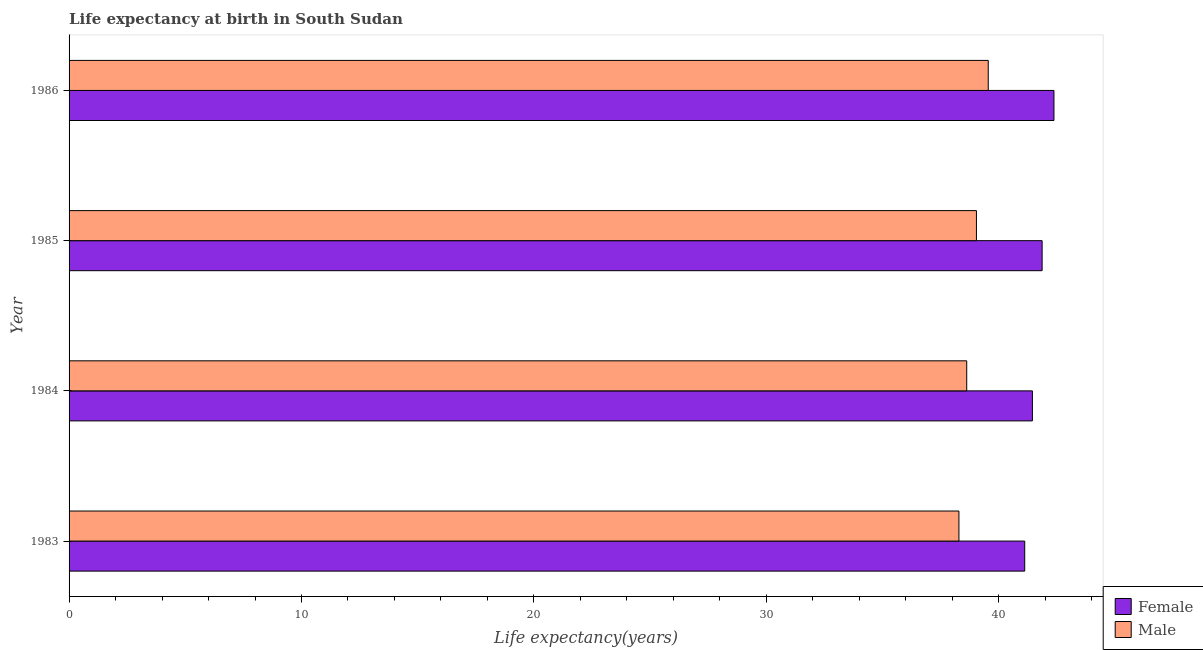How many different coloured bars are there?
Provide a short and direct response. 2. How many groups of bars are there?
Offer a terse response. 4. How many bars are there on the 3rd tick from the top?
Give a very brief answer. 2. How many bars are there on the 3rd tick from the bottom?
Provide a succinct answer. 2. What is the life expectancy(male) in 1986?
Keep it short and to the point. 39.55. Across all years, what is the maximum life expectancy(female)?
Give a very brief answer. 42.37. Across all years, what is the minimum life expectancy(male)?
Provide a succinct answer. 38.29. What is the total life expectancy(female) in the graph?
Your answer should be very brief. 166.8. What is the difference between the life expectancy(female) in 1984 and that in 1986?
Your response must be concise. -0.93. What is the difference between the life expectancy(female) in 1983 and the life expectancy(male) in 1986?
Provide a succinct answer. 1.57. What is the average life expectancy(female) per year?
Your answer should be compact. 41.7. In the year 1986, what is the difference between the life expectancy(male) and life expectancy(female)?
Your answer should be very brief. -2.83. What is the difference between the highest and the second highest life expectancy(female)?
Your response must be concise. 0.51. What is the difference between the highest and the lowest life expectancy(female)?
Give a very brief answer. 1.26. What does the 2nd bar from the top in 1983 represents?
Provide a succinct answer. Female. How many bars are there?
Make the answer very short. 8. How many years are there in the graph?
Your answer should be compact. 4. What is the difference between two consecutive major ticks on the X-axis?
Keep it short and to the point. 10. Does the graph contain any zero values?
Ensure brevity in your answer.  No. Where does the legend appear in the graph?
Your answer should be compact. Bottom right. How many legend labels are there?
Your answer should be compact. 2. How are the legend labels stacked?
Keep it short and to the point. Vertical. What is the title of the graph?
Keep it short and to the point. Life expectancy at birth in South Sudan. What is the label or title of the X-axis?
Your answer should be very brief. Life expectancy(years). What is the Life expectancy(years) of Female in 1983?
Your answer should be compact. 41.12. What is the Life expectancy(years) in Male in 1983?
Give a very brief answer. 38.29. What is the Life expectancy(years) of Female in 1984?
Ensure brevity in your answer.  41.45. What is the Life expectancy(years) in Male in 1984?
Provide a short and direct response. 38.62. What is the Life expectancy(years) in Female in 1985?
Offer a terse response. 41.87. What is the Life expectancy(years) of Male in 1985?
Your answer should be very brief. 39.04. What is the Life expectancy(years) in Female in 1986?
Provide a short and direct response. 42.37. What is the Life expectancy(years) in Male in 1986?
Give a very brief answer. 39.55. Across all years, what is the maximum Life expectancy(years) of Female?
Keep it short and to the point. 42.37. Across all years, what is the maximum Life expectancy(years) of Male?
Keep it short and to the point. 39.55. Across all years, what is the minimum Life expectancy(years) of Female?
Your response must be concise. 41.12. Across all years, what is the minimum Life expectancy(years) of Male?
Your answer should be very brief. 38.29. What is the total Life expectancy(years) of Female in the graph?
Ensure brevity in your answer.  166.8. What is the total Life expectancy(years) in Male in the graph?
Provide a succinct answer. 155.49. What is the difference between the Life expectancy(years) of Female in 1983 and that in 1984?
Your answer should be very brief. -0.33. What is the difference between the Life expectancy(years) in Male in 1983 and that in 1984?
Your answer should be compact. -0.34. What is the difference between the Life expectancy(years) in Female in 1983 and that in 1985?
Your answer should be very brief. -0.75. What is the difference between the Life expectancy(years) of Male in 1983 and that in 1985?
Offer a terse response. -0.75. What is the difference between the Life expectancy(years) in Female in 1983 and that in 1986?
Provide a short and direct response. -1.26. What is the difference between the Life expectancy(years) in Male in 1983 and that in 1986?
Provide a succinct answer. -1.26. What is the difference between the Life expectancy(years) in Female in 1984 and that in 1985?
Your answer should be very brief. -0.42. What is the difference between the Life expectancy(years) of Male in 1984 and that in 1985?
Keep it short and to the point. -0.42. What is the difference between the Life expectancy(years) in Female in 1984 and that in 1986?
Ensure brevity in your answer.  -0.93. What is the difference between the Life expectancy(years) of Male in 1984 and that in 1986?
Your answer should be very brief. -0.93. What is the difference between the Life expectancy(years) in Female in 1985 and that in 1986?
Keep it short and to the point. -0.51. What is the difference between the Life expectancy(years) of Male in 1985 and that in 1986?
Make the answer very short. -0.51. What is the difference between the Life expectancy(years) in Female in 1983 and the Life expectancy(years) in Male in 1984?
Your answer should be compact. 2.5. What is the difference between the Life expectancy(years) in Female in 1983 and the Life expectancy(years) in Male in 1985?
Make the answer very short. 2.08. What is the difference between the Life expectancy(years) in Female in 1983 and the Life expectancy(years) in Male in 1986?
Provide a succinct answer. 1.57. What is the difference between the Life expectancy(years) of Female in 1984 and the Life expectancy(years) of Male in 1985?
Provide a short and direct response. 2.41. What is the difference between the Life expectancy(years) of Female in 1984 and the Life expectancy(years) of Male in 1986?
Give a very brief answer. 1.9. What is the difference between the Life expectancy(years) in Female in 1985 and the Life expectancy(years) in Male in 1986?
Provide a short and direct response. 2.32. What is the average Life expectancy(years) of Female per year?
Your answer should be very brief. 41.7. What is the average Life expectancy(years) of Male per year?
Offer a very short reply. 38.87. In the year 1983, what is the difference between the Life expectancy(years) in Female and Life expectancy(years) in Male?
Offer a terse response. 2.83. In the year 1984, what is the difference between the Life expectancy(years) of Female and Life expectancy(years) of Male?
Make the answer very short. 2.83. In the year 1985, what is the difference between the Life expectancy(years) in Female and Life expectancy(years) in Male?
Keep it short and to the point. 2.83. In the year 1986, what is the difference between the Life expectancy(years) in Female and Life expectancy(years) in Male?
Your response must be concise. 2.83. What is the ratio of the Life expectancy(years) of Female in 1983 to that in 1984?
Offer a terse response. 0.99. What is the ratio of the Life expectancy(years) in Female in 1983 to that in 1985?
Offer a very short reply. 0.98. What is the ratio of the Life expectancy(years) in Male in 1983 to that in 1985?
Offer a terse response. 0.98. What is the ratio of the Life expectancy(years) of Female in 1983 to that in 1986?
Offer a very short reply. 0.97. What is the ratio of the Life expectancy(years) of Male in 1983 to that in 1986?
Ensure brevity in your answer.  0.97. What is the ratio of the Life expectancy(years) of Female in 1984 to that in 1985?
Your response must be concise. 0.99. What is the ratio of the Life expectancy(years) in Male in 1984 to that in 1985?
Give a very brief answer. 0.99. What is the ratio of the Life expectancy(years) in Female in 1984 to that in 1986?
Offer a very short reply. 0.98. What is the ratio of the Life expectancy(years) of Male in 1984 to that in 1986?
Your answer should be compact. 0.98. What is the ratio of the Life expectancy(years) of Male in 1985 to that in 1986?
Keep it short and to the point. 0.99. What is the difference between the highest and the second highest Life expectancy(years) in Female?
Ensure brevity in your answer.  0.51. What is the difference between the highest and the second highest Life expectancy(years) of Male?
Your answer should be very brief. 0.51. What is the difference between the highest and the lowest Life expectancy(years) in Female?
Ensure brevity in your answer.  1.26. What is the difference between the highest and the lowest Life expectancy(years) of Male?
Keep it short and to the point. 1.26. 